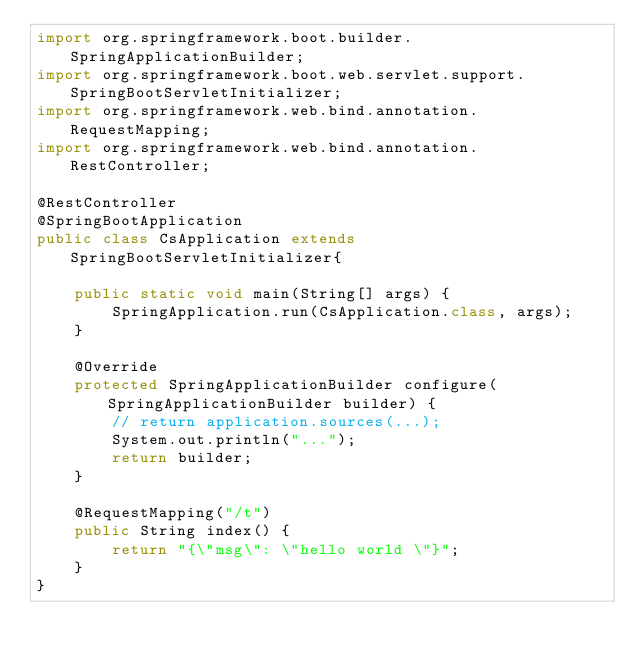<code> <loc_0><loc_0><loc_500><loc_500><_Java_>import org.springframework.boot.builder.SpringApplicationBuilder;
import org.springframework.boot.web.servlet.support.SpringBootServletInitializer;
import org.springframework.web.bind.annotation.RequestMapping;
import org.springframework.web.bind.annotation.RestController;

@RestController
@SpringBootApplication
public class CsApplication extends SpringBootServletInitializer{

	public static void main(String[] args) {
		SpringApplication.run(CsApplication.class, args);
	}
	
	@Override
    protected SpringApplicationBuilder configure(SpringApplicationBuilder builder) {
        // return application.sources(...);
		System.out.println("...");
		return builder;
    }

	@RequestMapping("/t")
	public String index() {
		return "{\"msg\": \"hello world \"}";
	}
}
</code> 